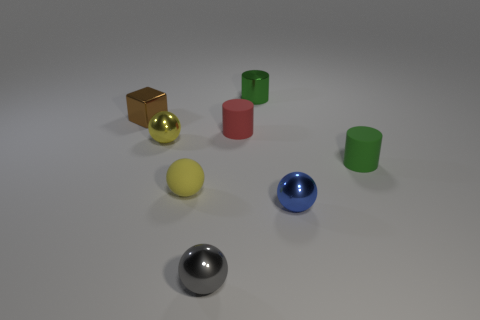Subtract 1 balls. How many balls are left? 3 Add 1 tiny balls. How many objects exist? 9 Subtract all cubes. How many objects are left? 7 Add 6 metal cylinders. How many metal cylinders exist? 7 Subtract 1 red cylinders. How many objects are left? 7 Subtract all tiny yellow shiny objects. Subtract all rubber spheres. How many objects are left? 6 Add 3 yellow rubber objects. How many yellow rubber objects are left? 4 